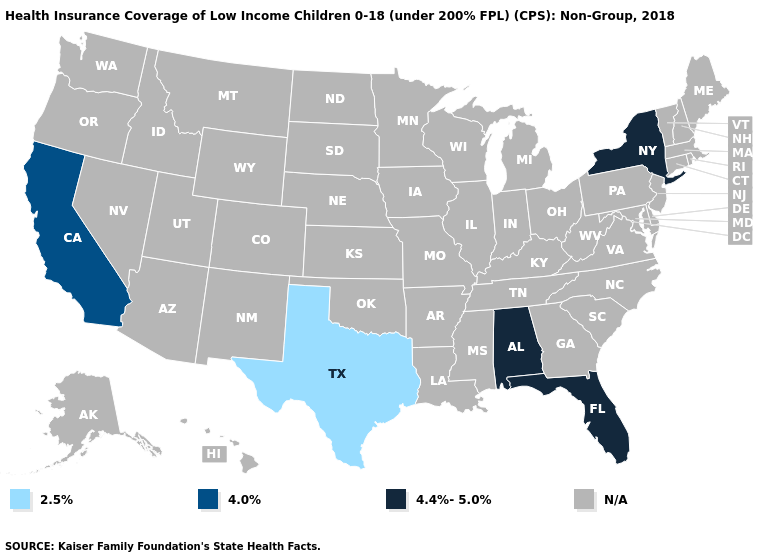Is the legend a continuous bar?
Short answer required. No. What is the value of Rhode Island?
Write a very short answer. N/A. Name the states that have a value in the range N/A?
Write a very short answer. Alaska, Arizona, Arkansas, Colorado, Connecticut, Delaware, Georgia, Hawaii, Idaho, Illinois, Indiana, Iowa, Kansas, Kentucky, Louisiana, Maine, Maryland, Massachusetts, Michigan, Minnesota, Mississippi, Missouri, Montana, Nebraska, Nevada, New Hampshire, New Jersey, New Mexico, North Carolina, North Dakota, Ohio, Oklahoma, Oregon, Pennsylvania, Rhode Island, South Carolina, South Dakota, Tennessee, Utah, Vermont, Virginia, Washington, West Virginia, Wisconsin, Wyoming. Name the states that have a value in the range 2.5%?
Answer briefly. Texas. What is the value of Maine?
Be succinct. N/A. What is the value of Utah?
Short answer required. N/A. What is the highest value in the USA?
Give a very brief answer. 4.4%-5.0%. Which states hav the highest value in the West?
Write a very short answer. California. Name the states that have a value in the range 2.5%?
Quick response, please. Texas. Name the states that have a value in the range N/A?
Write a very short answer. Alaska, Arizona, Arkansas, Colorado, Connecticut, Delaware, Georgia, Hawaii, Idaho, Illinois, Indiana, Iowa, Kansas, Kentucky, Louisiana, Maine, Maryland, Massachusetts, Michigan, Minnesota, Mississippi, Missouri, Montana, Nebraska, Nevada, New Hampshire, New Jersey, New Mexico, North Carolina, North Dakota, Ohio, Oklahoma, Oregon, Pennsylvania, Rhode Island, South Carolina, South Dakota, Tennessee, Utah, Vermont, Virginia, Washington, West Virginia, Wisconsin, Wyoming. What is the highest value in the USA?
Give a very brief answer. 4.4%-5.0%. What is the value of Maryland?
Concise answer only. N/A. 